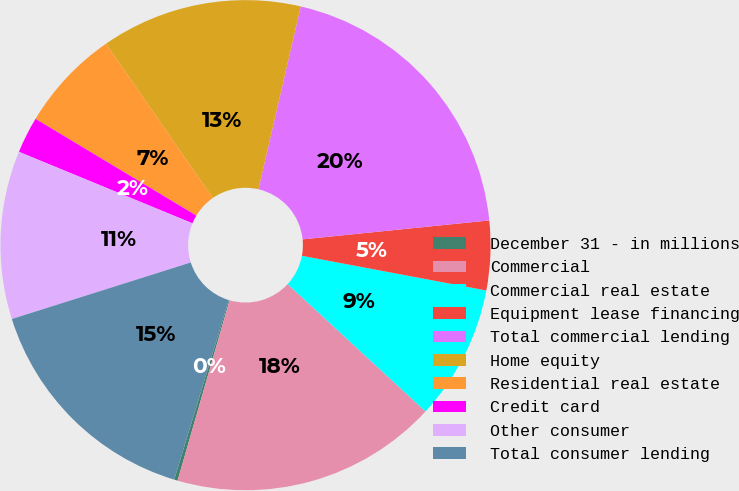Convert chart. <chart><loc_0><loc_0><loc_500><loc_500><pie_chart><fcel>December 31 - in millions<fcel>Commercial<fcel>Commercial real estate<fcel>Equipment lease financing<fcel>Total commercial lending<fcel>Home equity<fcel>Residential real estate<fcel>Credit card<fcel>Other consumer<fcel>Total consumer lending<nl><fcel>0.23%<fcel>17.6%<fcel>8.91%<fcel>4.57%<fcel>19.77%<fcel>13.26%<fcel>6.74%<fcel>2.4%<fcel>11.09%<fcel>15.43%<nl></chart> 